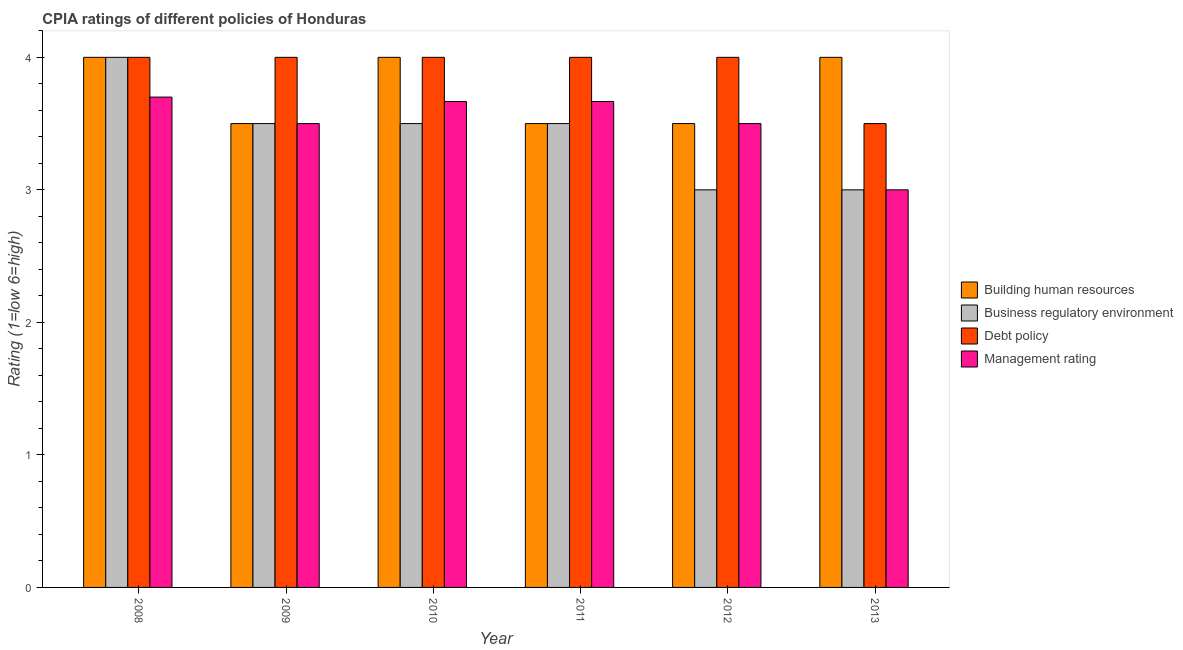How many different coloured bars are there?
Provide a succinct answer. 4. Are the number of bars per tick equal to the number of legend labels?
Your answer should be very brief. Yes. Are the number of bars on each tick of the X-axis equal?
Give a very brief answer. Yes. How many bars are there on the 2nd tick from the right?
Provide a succinct answer. 4. What is the label of the 5th group of bars from the left?
Offer a terse response. 2012. In how many cases, is the number of bars for a given year not equal to the number of legend labels?
Your answer should be very brief. 0. Across all years, what is the maximum cpia rating of building human resources?
Offer a very short reply. 4. In which year was the cpia rating of business regulatory environment minimum?
Keep it short and to the point. 2012. What is the total cpia rating of business regulatory environment in the graph?
Your answer should be very brief. 20.5. What is the difference between the cpia rating of debt policy in 2009 and the cpia rating of management in 2013?
Your answer should be compact. 0.5. What is the average cpia rating of business regulatory environment per year?
Keep it short and to the point. 3.42. Is the difference between the cpia rating of building human resources in 2010 and 2012 greater than the difference between the cpia rating of business regulatory environment in 2010 and 2012?
Provide a short and direct response. No. What is the difference between the highest and the lowest cpia rating of business regulatory environment?
Provide a succinct answer. 1. Is it the case that in every year, the sum of the cpia rating of management and cpia rating of building human resources is greater than the sum of cpia rating of debt policy and cpia rating of business regulatory environment?
Ensure brevity in your answer.  No. What does the 2nd bar from the left in 2011 represents?
Provide a short and direct response. Business regulatory environment. What does the 4th bar from the right in 2013 represents?
Keep it short and to the point. Building human resources. Is it the case that in every year, the sum of the cpia rating of building human resources and cpia rating of business regulatory environment is greater than the cpia rating of debt policy?
Offer a very short reply. Yes. Are all the bars in the graph horizontal?
Give a very brief answer. No. How many legend labels are there?
Provide a succinct answer. 4. How are the legend labels stacked?
Provide a succinct answer. Vertical. What is the title of the graph?
Ensure brevity in your answer.  CPIA ratings of different policies of Honduras. Does "France" appear as one of the legend labels in the graph?
Provide a short and direct response. No. What is the Rating (1=low 6=high) of Building human resources in 2008?
Give a very brief answer. 4. What is the Rating (1=low 6=high) of Building human resources in 2009?
Ensure brevity in your answer.  3.5. What is the Rating (1=low 6=high) of Debt policy in 2009?
Offer a very short reply. 4. What is the Rating (1=low 6=high) in Management rating in 2010?
Make the answer very short. 3.67. What is the Rating (1=low 6=high) in Business regulatory environment in 2011?
Provide a short and direct response. 3.5. What is the Rating (1=low 6=high) of Debt policy in 2011?
Give a very brief answer. 4. What is the Rating (1=low 6=high) of Management rating in 2011?
Provide a succinct answer. 3.67. What is the Rating (1=low 6=high) in Business regulatory environment in 2013?
Make the answer very short. 3. Across all years, what is the maximum Rating (1=low 6=high) in Management rating?
Your answer should be very brief. 3.7. Across all years, what is the minimum Rating (1=low 6=high) of Business regulatory environment?
Provide a succinct answer. 3. What is the total Rating (1=low 6=high) of Building human resources in the graph?
Your answer should be compact. 22.5. What is the total Rating (1=low 6=high) of Management rating in the graph?
Your answer should be compact. 21.03. What is the difference between the Rating (1=low 6=high) in Management rating in 2008 and that in 2009?
Provide a succinct answer. 0.2. What is the difference between the Rating (1=low 6=high) in Debt policy in 2008 and that in 2010?
Provide a succinct answer. 0. What is the difference between the Rating (1=low 6=high) of Management rating in 2008 and that in 2010?
Make the answer very short. 0.03. What is the difference between the Rating (1=low 6=high) in Building human resources in 2008 and that in 2012?
Provide a short and direct response. 0.5. What is the difference between the Rating (1=low 6=high) in Debt policy in 2008 and that in 2012?
Ensure brevity in your answer.  0. What is the difference between the Rating (1=low 6=high) of Management rating in 2008 and that in 2012?
Your answer should be very brief. 0.2. What is the difference between the Rating (1=low 6=high) of Building human resources in 2009 and that in 2010?
Keep it short and to the point. -0.5. What is the difference between the Rating (1=low 6=high) of Debt policy in 2009 and that in 2011?
Provide a succinct answer. 0. What is the difference between the Rating (1=low 6=high) of Management rating in 2009 and that in 2011?
Keep it short and to the point. -0.17. What is the difference between the Rating (1=low 6=high) of Building human resources in 2009 and that in 2012?
Provide a succinct answer. 0. What is the difference between the Rating (1=low 6=high) in Debt policy in 2009 and that in 2013?
Give a very brief answer. 0.5. What is the difference between the Rating (1=low 6=high) in Management rating in 2009 and that in 2013?
Offer a terse response. 0.5. What is the difference between the Rating (1=low 6=high) in Business regulatory environment in 2010 and that in 2011?
Offer a terse response. 0. What is the difference between the Rating (1=low 6=high) of Management rating in 2010 and that in 2011?
Your answer should be very brief. 0. What is the difference between the Rating (1=low 6=high) in Business regulatory environment in 2010 and that in 2012?
Your response must be concise. 0.5. What is the difference between the Rating (1=low 6=high) of Building human resources in 2010 and that in 2013?
Keep it short and to the point. 0. What is the difference between the Rating (1=low 6=high) of Management rating in 2010 and that in 2013?
Your answer should be very brief. 0.67. What is the difference between the Rating (1=low 6=high) in Business regulatory environment in 2011 and that in 2012?
Offer a terse response. 0.5. What is the difference between the Rating (1=low 6=high) of Debt policy in 2011 and that in 2013?
Make the answer very short. 0.5. What is the difference between the Rating (1=low 6=high) in Business regulatory environment in 2012 and that in 2013?
Your answer should be compact. 0. What is the difference between the Rating (1=low 6=high) in Debt policy in 2012 and that in 2013?
Your answer should be compact. 0.5. What is the difference between the Rating (1=low 6=high) in Management rating in 2012 and that in 2013?
Offer a very short reply. 0.5. What is the difference between the Rating (1=low 6=high) of Building human resources in 2008 and the Rating (1=low 6=high) of Management rating in 2009?
Provide a short and direct response. 0.5. What is the difference between the Rating (1=low 6=high) in Debt policy in 2008 and the Rating (1=low 6=high) in Management rating in 2009?
Make the answer very short. 0.5. What is the difference between the Rating (1=low 6=high) in Building human resources in 2008 and the Rating (1=low 6=high) in Business regulatory environment in 2010?
Provide a succinct answer. 0.5. What is the difference between the Rating (1=low 6=high) in Building human resources in 2008 and the Rating (1=low 6=high) in Management rating in 2010?
Offer a very short reply. 0.33. What is the difference between the Rating (1=low 6=high) in Business regulatory environment in 2008 and the Rating (1=low 6=high) in Management rating in 2010?
Keep it short and to the point. 0.33. What is the difference between the Rating (1=low 6=high) of Business regulatory environment in 2008 and the Rating (1=low 6=high) of Debt policy in 2011?
Offer a terse response. 0. What is the difference between the Rating (1=low 6=high) in Building human resources in 2008 and the Rating (1=low 6=high) in Business regulatory environment in 2012?
Give a very brief answer. 1. What is the difference between the Rating (1=low 6=high) of Building human resources in 2008 and the Rating (1=low 6=high) of Debt policy in 2012?
Your answer should be compact. 0. What is the difference between the Rating (1=low 6=high) in Business regulatory environment in 2008 and the Rating (1=low 6=high) in Debt policy in 2012?
Give a very brief answer. 0. What is the difference between the Rating (1=low 6=high) of Business regulatory environment in 2008 and the Rating (1=low 6=high) of Management rating in 2012?
Provide a short and direct response. 0.5. What is the difference between the Rating (1=low 6=high) in Building human resources in 2008 and the Rating (1=low 6=high) in Business regulatory environment in 2013?
Your answer should be compact. 1. What is the difference between the Rating (1=low 6=high) of Building human resources in 2009 and the Rating (1=low 6=high) of Debt policy in 2010?
Make the answer very short. -0.5. What is the difference between the Rating (1=low 6=high) of Building human resources in 2009 and the Rating (1=low 6=high) of Management rating in 2010?
Keep it short and to the point. -0.17. What is the difference between the Rating (1=low 6=high) in Building human resources in 2009 and the Rating (1=low 6=high) in Management rating in 2011?
Your answer should be compact. -0.17. What is the difference between the Rating (1=low 6=high) of Business regulatory environment in 2009 and the Rating (1=low 6=high) of Debt policy in 2011?
Provide a short and direct response. -0.5. What is the difference between the Rating (1=low 6=high) of Business regulatory environment in 2009 and the Rating (1=low 6=high) of Management rating in 2011?
Offer a very short reply. -0.17. What is the difference between the Rating (1=low 6=high) of Debt policy in 2009 and the Rating (1=low 6=high) of Management rating in 2011?
Keep it short and to the point. 0.33. What is the difference between the Rating (1=low 6=high) of Building human resources in 2009 and the Rating (1=low 6=high) of Business regulatory environment in 2012?
Ensure brevity in your answer.  0.5. What is the difference between the Rating (1=low 6=high) in Building human resources in 2009 and the Rating (1=low 6=high) in Debt policy in 2012?
Offer a terse response. -0.5. What is the difference between the Rating (1=low 6=high) of Business regulatory environment in 2009 and the Rating (1=low 6=high) of Management rating in 2012?
Keep it short and to the point. 0. What is the difference between the Rating (1=low 6=high) of Building human resources in 2009 and the Rating (1=low 6=high) of Business regulatory environment in 2013?
Your answer should be compact. 0.5. What is the difference between the Rating (1=low 6=high) of Building human resources in 2009 and the Rating (1=low 6=high) of Management rating in 2013?
Give a very brief answer. 0.5. What is the difference between the Rating (1=low 6=high) of Building human resources in 2010 and the Rating (1=low 6=high) of Business regulatory environment in 2011?
Offer a terse response. 0.5. What is the difference between the Rating (1=low 6=high) in Building human resources in 2010 and the Rating (1=low 6=high) in Debt policy in 2011?
Your response must be concise. 0. What is the difference between the Rating (1=low 6=high) of Building human resources in 2010 and the Rating (1=low 6=high) of Management rating in 2011?
Provide a succinct answer. 0.33. What is the difference between the Rating (1=low 6=high) in Business regulatory environment in 2010 and the Rating (1=low 6=high) in Debt policy in 2011?
Give a very brief answer. -0.5. What is the difference between the Rating (1=low 6=high) in Building human resources in 2010 and the Rating (1=low 6=high) in Business regulatory environment in 2012?
Give a very brief answer. 1. What is the difference between the Rating (1=low 6=high) in Building human resources in 2010 and the Rating (1=low 6=high) in Debt policy in 2012?
Your answer should be compact. 0. What is the difference between the Rating (1=low 6=high) in Building human resources in 2010 and the Rating (1=low 6=high) in Management rating in 2012?
Your answer should be compact. 0.5. What is the difference between the Rating (1=low 6=high) of Business regulatory environment in 2010 and the Rating (1=low 6=high) of Debt policy in 2012?
Provide a succinct answer. -0.5. What is the difference between the Rating (1=low 6=high) of Business regulatory environment in 2010 and the Rating (1=low 6=high) of Management rating in 2012?
Your answer should be compact. 0. What is the difference between the Rating (1=low 6=high) of Debt policy in 2010 and the Rating (1=low 6=high) of Management rating in 2012?
Give a very brief answer. 0.5. What is the difference between the Rating (1=low 6=high) of Building human resources in 2010 and the Rating (1=low 6=high) of Business regulatory environment in 2013?
Keep it short and to the point. 1. What is the difference between the Rating (1=low 6=high) in Building human resources in 2010 and the Rating (1=low 6=high) in Management rating in 2013?
Provide a short and direct response. 1. What is the difference between the Rating (1=low 6=high) in Business regulatory environment in 2010 and the Rating (1=low 6=high) in Management rating in 2013?
Your answer should be compact. 0.5. What is the difference between the Rating (1=low 6=high) in Building human resources in 2011 and the Rating (1=low 6=high) in Management rating in 2012?
Offer a terse response. 0. What is the difference between the Rating (1=low 6=high) of Debt policy in 2011 and the Rating (1=low 6=high) of Management rating in 2012?
Keep it short and to the point. 0.5. What is the difference between the Rating (1=low 6=high) of Building human resources in 2011 and the Rating (1=low 6=high) of Business regulatory environment in 2013?
Give a very brief answer. 0.5. What is the difference between the Rating (1=low 6=high) in Building human resources in 2011 and the Rating (1=low 6=high) in Management rating in 2013?
Your response must be concise. 0.5. What is the difference between the Rating (1=low 6=high) in Debt policy in 2011 and the Rating (1=low 6=high) in Management rating in 2013?
Offer a terse response. 1. What is the difference between the Rating (1=low 6=high) of Building human resources in 2012 and the Rating (1=low 6=high) of Debt policy in 2013?
Provide a short and direct response. 0. What is the difference between the Rating (1=low 6=high) in Building human resources in 2012 and the Rating (1=low 6=high) in Management rating in 2013?
Make the answer very short. 0.5. What is the difference between the Rating (1=low 6=high) of Business regulatory environment in 2012 and the Rating (1=low 6=high) of Debt policy in 2013?
Keep it short and to the point. -0.5. What is the average Rating (1=low 6=high) of Building human resources per year?
Keep it short and to the point. 3.75. What is the average Rating (1=low 6=high) of Business regulatory environment per year?
Your answer should be very brief. 3.42. What is the average Rating (1=low 6=high) of Debt policy per year?
Provide a short and direct response. 3.92. What is the average Rating (1=low 6=high) of Management rating per year?
Offer a terse response. 3.51. In the year 2008, what is the difference between the Rating (1=low 6=high) of Building human resources and Rating (1=low 6=high) of Business regulatory environment?
Your answer should be very brief. 0. In the year 2008, what is the difference between the Rating (1=low 6=high) of Building human resources and Rating (1=low 6=high) of Debt policy?
Ensure brevity in your answer.  0. In the year 2010, what is the difference between the Rating (1=low 6=high) of Business regulatory environment and Rating (1=low 6=high) of Debt policy?
Offer a terse response. -0.5. In the year 2010, what is the difference between the Rating (1=low 6=high) in Business regulatory environment and Rating (1=low 6=high) in Management rating?
Offer a very short reply. -0.17. In the year 2010, what is the difference between the Rating (1=low 6=high) of Debt policy and Rating (1=low 6=high) of Management rating?
Offer a terse response. 0.33. In the year 2011, what is the difference between the Rating (1=low 6=high) of Building human resources and Rating (1=low 6=high) of Debt policy?
Make the answer very short. -0.5. In the year 2011, what is the difference between the Rating (1=low 6=high) in Business regulatory environment and Rating (1=low 6=high) in Management rating?
Give a very brief answer. -0.17. In the year 2011, what is the difference between the Rating (1=low 6=high) of Debt policy and Rating (1=low 6=high) of Management rating?
Your answer should be very brief. 0.33. In the year 2012, what is the difference between the Rating (1=low 6=high) in Building human resources and Rating (1=low 6=high) in Debt policy?
Your answer should be compact. -0.5. In the year 2012, what is the difference between the Rating (1=low 6=high) in Business regulatory environment and Rating (1=low 6=high) in Management rating?
Your response must be concise. -0.5. In the year 2013, what is the difference between the Rating (1=low 6=high) of Building human resources and Rating (1=low 6=high) of Debt policy?
Keep it short and to the point. 0.5. In the year 2013, what is the difference between the Rating (1=low 6=high) of Building human resources and Rating (1=low 6=high) of Management rating?
Ensure brevity in your answer.  1. In the year 2013, what is the difference between the Rating (1=low 6=high) of Business regulatory environment and Rating (1=low 6=high) of Management rating?
Your answer should be compact. 0. In the year 2013, what is the difference between the Rating (1=low 6=high) in Debt policy and Rating (1=low 6=high) in Management rating?
Provide a short and direct response. 0.5. What is the ratio of the Rating (1=low 6=high) of Business regulatory environment in 2008 to that in 2009?
Ensure brevity in your answer.  1.14. What is the ratio of the Rating (1=low 6=high) of Management rating in 2008 to that in 2009?
Ensure brevity in your answer.  1.06. What is the ratio of the Rating (1=low 6=high) of Building human resources in 2008 to that in 2010?
Provide a succinct answer. 1. What is the ratio of the Rating (1=low 6=high) in Debt policy in 2008 to that in 2010?
Your response must be concise. 1. What is the ratio of the Rating (1=low 6=high) in Management rating in 2008 to that in 2010?
Your answer should be very brief. 1.01. What is the ratio of the Rating (1=low 6=high) of Management rating in 2008 to that in 2011?
Provide a succinct answer. 1.01. What is the ratio of the Rating (1=low 6=high) of Management rating in 2008 to that in 2012?
Make the answer very short. 1.06. What is the ratio of the Rating (1=low 6=high) in Business regulatory environment in 2008 to that in 2013?
Your answer should be compact. 1.33. What is the ratio of the Rating (1=low 6=high) of Debt policy in 2008 to that in 2013?
Offer a terse response. 1.14. What is the ratio of the Rating (1=low 6=high) of Management rating in 2008 to that in 2013?
Your answer should be compact. 1.23. What is the ratio of the Rating (1=low 6=high) of Business regulatory environment in 2009 to that in 2010?
Offer a terse response. 1. What is the ratio of the Rating (1=low 6=high) of Debt policy in 2009 to that in 2010?
Provide a short and direct response. 1. What is the ratio of the Rating (1=low 6=high) in Management rating in 2009 to that in 2010?
Provide a succinct answer. 0.95. What is the ratio of the Rating (1=low 6=high) of Management rating in 2009 to that in 2011?
Your answer should be very brief. 0.95. What is the ratio of the Rating (1=low 6=high) of Management rating in 2009 to that in 2012?
Provide a short and direct response. 1. What is the ratio of the Rating (1=low 6=high) in Building human resources in 2009 to that in 2013?
Offer a very short reply. 0.88. What is the ratio of the Rating (1=low 6=high) in Business regulatory environment in 2009 to that in 2013?
Offer a terse response. 1.17. What is the ratio of the Rating (1=low 6=high) in Debt policy in 2009 to that in 2013?
Offer a very short reply. 1.14. What is the ratio of the Rating (1=low 6=high) of Management rating in 2009 to that in 2013?
Keep it short and to the point. 1.17. What is the ratio of the Rating (1=low 6=high) of Debt policy in 2010 to that in 2011?
Provide a short and direct response. 1. What is the ratio of the Rating (1=low 6=high) of Management rating in 2010 to that in 2011?
Offer a terse response. 1. What is the ratio of the Rating (1=low 6=high) of Business regulatory environment in 2010 to that in 2012?
Ensure brevity in your answer.  1.17. What is the ratio of the Rating (1=low 6=high) in Management rating in 2010 to that in 2012?
Give a very brief answer. 1.05. What is the ratio of the Rating (1=low 6=high) of Debt policy in 2010 to that in 2013?
Your answer should be very brief. 1.14. What is the ratio of the Rating (1=low 6=high) of Management rating in 2010 to that in 2013?
Make the answer very short. 1.22. What is the ratio of the Rating (1=low 6=high) of Building human resources in 2011 to that in 2012?
Give a very brief answer. 1. What is the ratio of the Rating (1=low 6=high) in Business regulatory environment in 2011 to that in 2012?
Your answer should be compact. 1.17. What is the ratio of the Rating (1=low 6=high) in Debt policy in 2011 to that in 2012?
Your answer should be compact. 1. What is the ratio of the Rating (1=low 6=high) of Management rating in 2011 to that in 2012?
Provide a short and direct response. 1.05. What is the ratio of the Rating (1=low 6=high) in Building human resources in 2011 to that in 2013?
Offer a very short reply. 0.88. What is the ratio of the Rating (1=low 6=high) of Business regulatory environment in 2011 to that in 2013?
Ensure brevity in your answer.  1.17. What is the ratio of the Rating (1=low 6=high) of Management rating in 2011 to that in 2013?
Keep it short and to the point. 1.22. What is the ratio of the Rating (1=low 6=high) of Debt policy in 2012 to that in 2013?
Offer a terse response. 1.14. What is the ratio of the Rating (1=low 6=high) in Management rating in 2012 to that in 2013?
Offer a terse response. 1.17. What is the difference between the highest and the second highest Rating (1=low 6=high) in Building human resources?
Ensure brevity in your answer.  0. What is the difference between the highest and the lowest Rating (1=low 6=high) of Building human resources?
Offer a terse response. 0.5. What is the difference between the highest and the lowest Rating (1=low 6=high) of Business regulatory environment?
Offer a very short reply. 1. What is the difference between the highest and the lowest Rating (1=low 6=high) in Debt policy?
Provide a short and direct response. 0.5. 